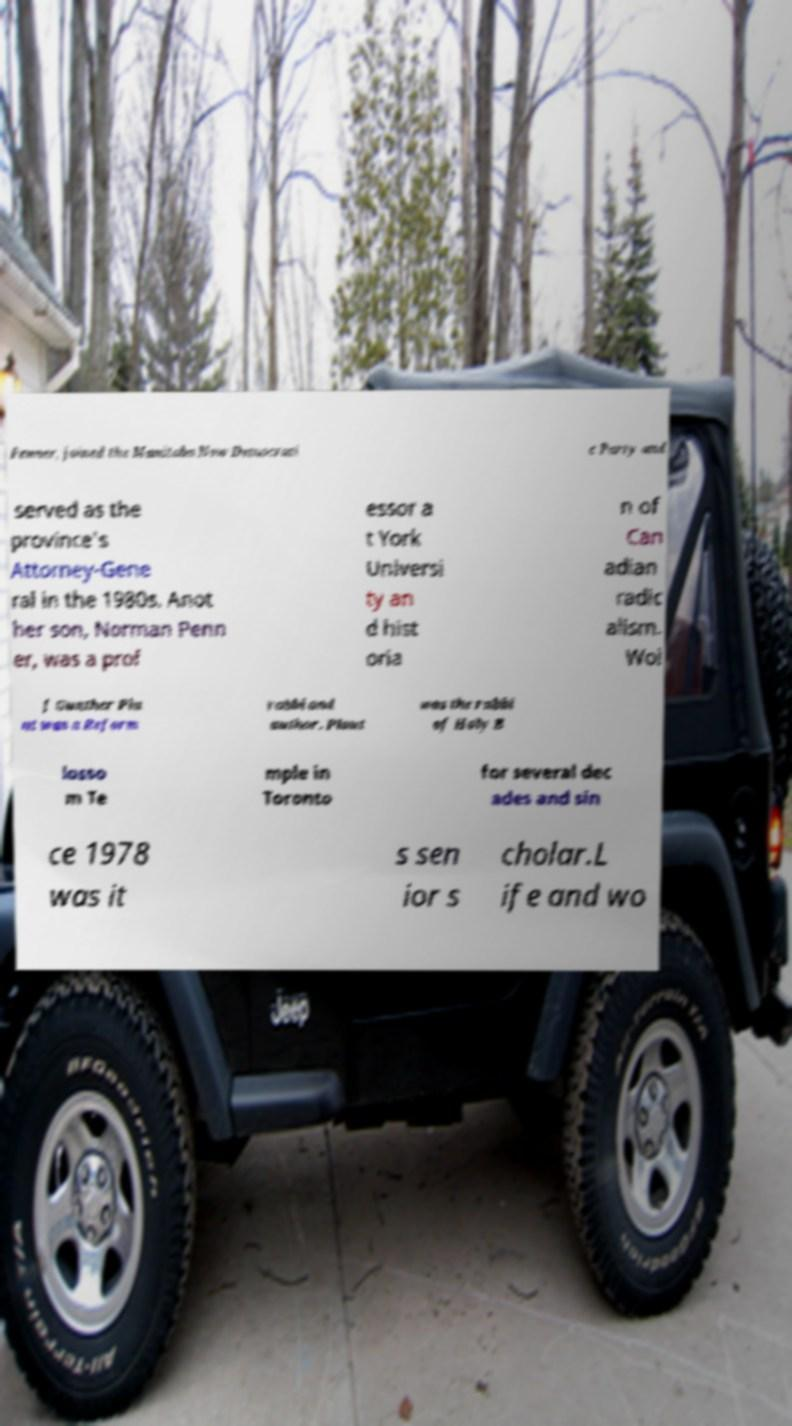Can you read and provide the text displayed in the image?This photo seems to have some interesting text. Can you extract and type it out for me? Penner, joined the Manitoba New Democrati c Party and served as the province's Attorney-Gene ral in the 1980s. Anot her son, Norman Penn er, was a prof essor a t York Universi ty an d hist oria n of Can adian radic alism. Wol f Gunther Pla ut was a Reform rabbi and author. Plaut was the rabbi of Holy B losso m Te mple in Toronto for several dec ades and sin ce 1978 was it s sen ior s cholar.L ife and wo 